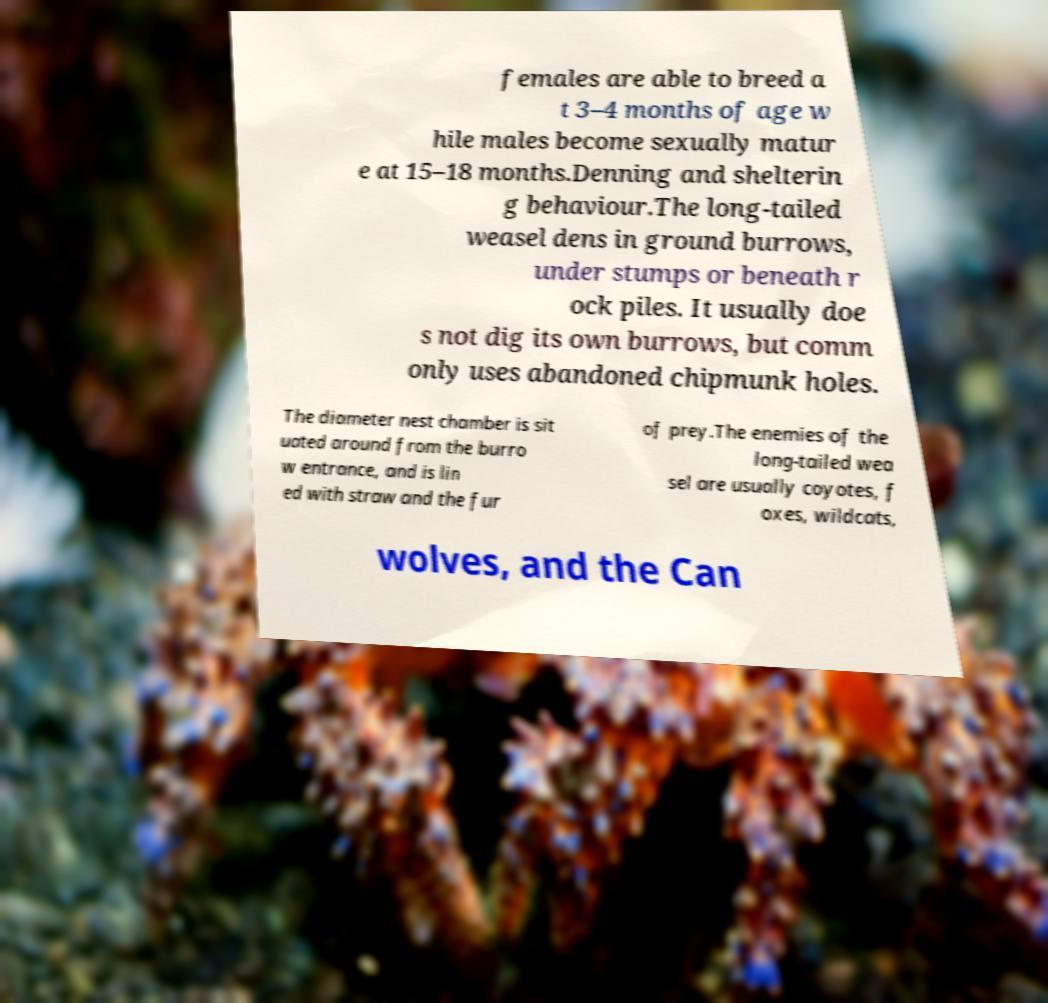Can you accurately transcribe the text from the provided image for me? females are able to breed a t 3–4 months of age w hile males become sexually matur e at 15–18 months.Denning and shelterin g behaviour.The long-tailed weasel dens in ground burrows, under stumps or beneath r ock piles. It usually doe s not dig its own burrows, but comm only uses abandoned chipmunk holes. The diameter nest chamber is sit uated around from the burro w entrance, and is lin ed with straw and the fur of prey.The enemies of the long-tailed wea sel are usually coyotes, f oxes, wildcats, wolves, and the Can 